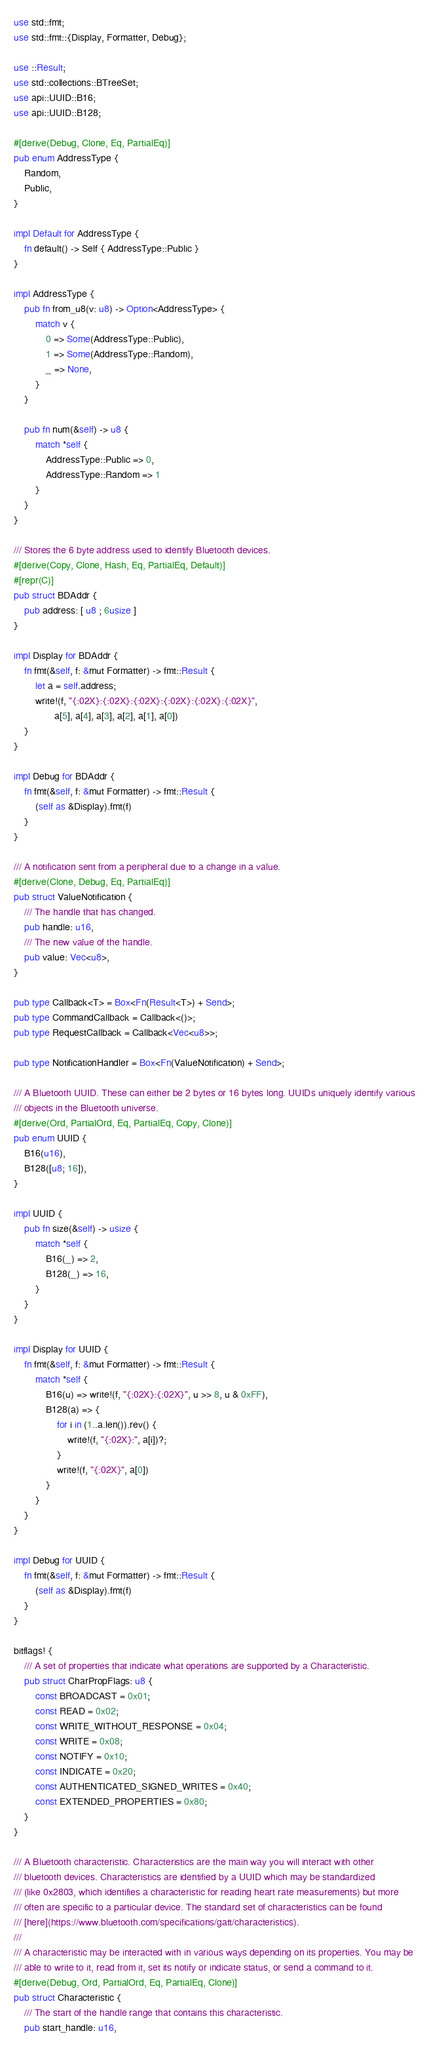<code> <loc_0><loc_0><loc_500><loc_500><_Rust_>use std::fmt;
use std::fmt::{Display, Formatter, Debug};

use ::Result;
use std::collections::BTreeSet;
use api::UUID::B16;
use api::UUID::B128;

#[derive(Debug, Clone, Eq, PartialEq)]
pub enum AddressType {
    Random,
    Public,
}

impl Default for AddressType {
    fn default() -> Self { AddressType::Public }
}

impl AddressType {
    pub fn from_u8(v: u8) -> Option<AddressType> {
        match v {
            0 => Some(AddressType::Public),
            1 => Some(AddressType::Random),
            _ => None,
        }
    }

    pub fn num(&self) -> u8 {
        match *self {
            AddressType::Public => 0,
            AddressType::Random => 1
        }
    }
}

/// Stores the 6 byte address used to identify Bluetooth devices.
#[derive(Copy, Clone, Hash, Eq, PartialEq, Default)]
#[repr(C)]
pub struct BDAddr {
    pub address: [ u8 ; 6usize ]
}

impl Display for BDAddr {
    fn fmt(&self, f: &mut Formatter) -> fmt::Result {
        let a = self.address;
        write!(f, "{:02X}:{:02X}:{:02X}:{:02X}:{:02X}:{:02X}",
               a[5], a[4], a[3], a[2], a[1], a[0])
    }
}

impl Debug for BDAddr {
    fn fmt(&self, f: &mut Formatter) -> fmt::Result {
        (self as &Display).fmt(f)
    }
}

/// A notification sent from a peripheral due to a change in a value.
#[derive(Clone, Debug, Eq, PartialEq)]
pub struct ValueNotification {
    /// The handle that has changed.
    pub handle: u16,
    /// The new value of the handle.
    pub value: Vec<u8>,
}

pub type Callback<T> = Box<Fn(Result<T>) + Send>;
pub type CommandCallback = Callback<()>;
pub type RequestCallback = Callback<Vec<u8>>;

pub type NotificationHandler = Box<Fn(ValueNotification) + Send>;

/// A Bluetooth UUID. These can either be 2 bytes or 16 bytes long. UUIDs uniquely identify various
/// objects in the Bluetooth universe.
#[derive(Ord, PartialOrd, Eq, PartialEq, Copy, Clone)]
pub enum UUID {
    B16(u16),
    B128([u8; 16]),
}

impl UUID {
    pub fn size(&self) -> usize {
        match *self {
            B16(_) => 2,
            B128(_) => 16,
        }
    }
}

impl Display for UUID {
    fn fmt(&self, f: &mut Formatter) -> fmt::Result {
        match *self {
            B16(u) => write!(f, "{:02X}:{:02X}", u >> 8, u & 0xFF),
            B128(a) => {
                for i in (1..a.len()).rev() {
                    write!(f, "{:02X}:", a[i])?;
                }
                write!(f, "{:02X}", a[0])
            }
        }
    }
}

impl Debug for UUID {
    fn fmt(&self, f: &mut Formatter) -> fmt::Result {
        (self as &Display).fmt(f)
    }
}

bitflags! {
    /// A set of properties that indicate what operations are supported by a Characteristic.
    pub struct CharPropFlags: u8 {
        const BROADCAST = 0x01;
        const READ = 0x02;
        const WRITE_WITHOUT_RESPONSE = 0x04;
        const WRITE = 0x08;
        const NOTIFY = 0x10;
        const INDICATE = 0x20;
        const AUTHENTICATED_SIGNED_WRITES = 0x40;
        const EXTENDED_PROPERTIES = 0x80;
    }
}

/// A Bluetooth characteristic. Characteristics are the main way you will interact with other
/// bluetooth devices. Characteristics are identified by a UUID which may be standardized
/// (like 0x2803, which identifies a characteristic for reading heart rate measurements) but more
/// often are specific to a particular device. The standard set of characteristics can be found
/// [here](https://www.bluetooth.com/specifications/gatt/characteristics).
///
/// A characteristic may be interacted with in various ways depending on its properties. You may be
/// able to write to it, read from it, set its notify or indicate status, or send a command to it.
#[derive(Debug, Ord, PartialOrd, Eq, PartialEq, Clone)]
pub struct Characteristic {
    /// The start of the handle range that contains this characteristic.
    pub start_handle: u16,</code> 